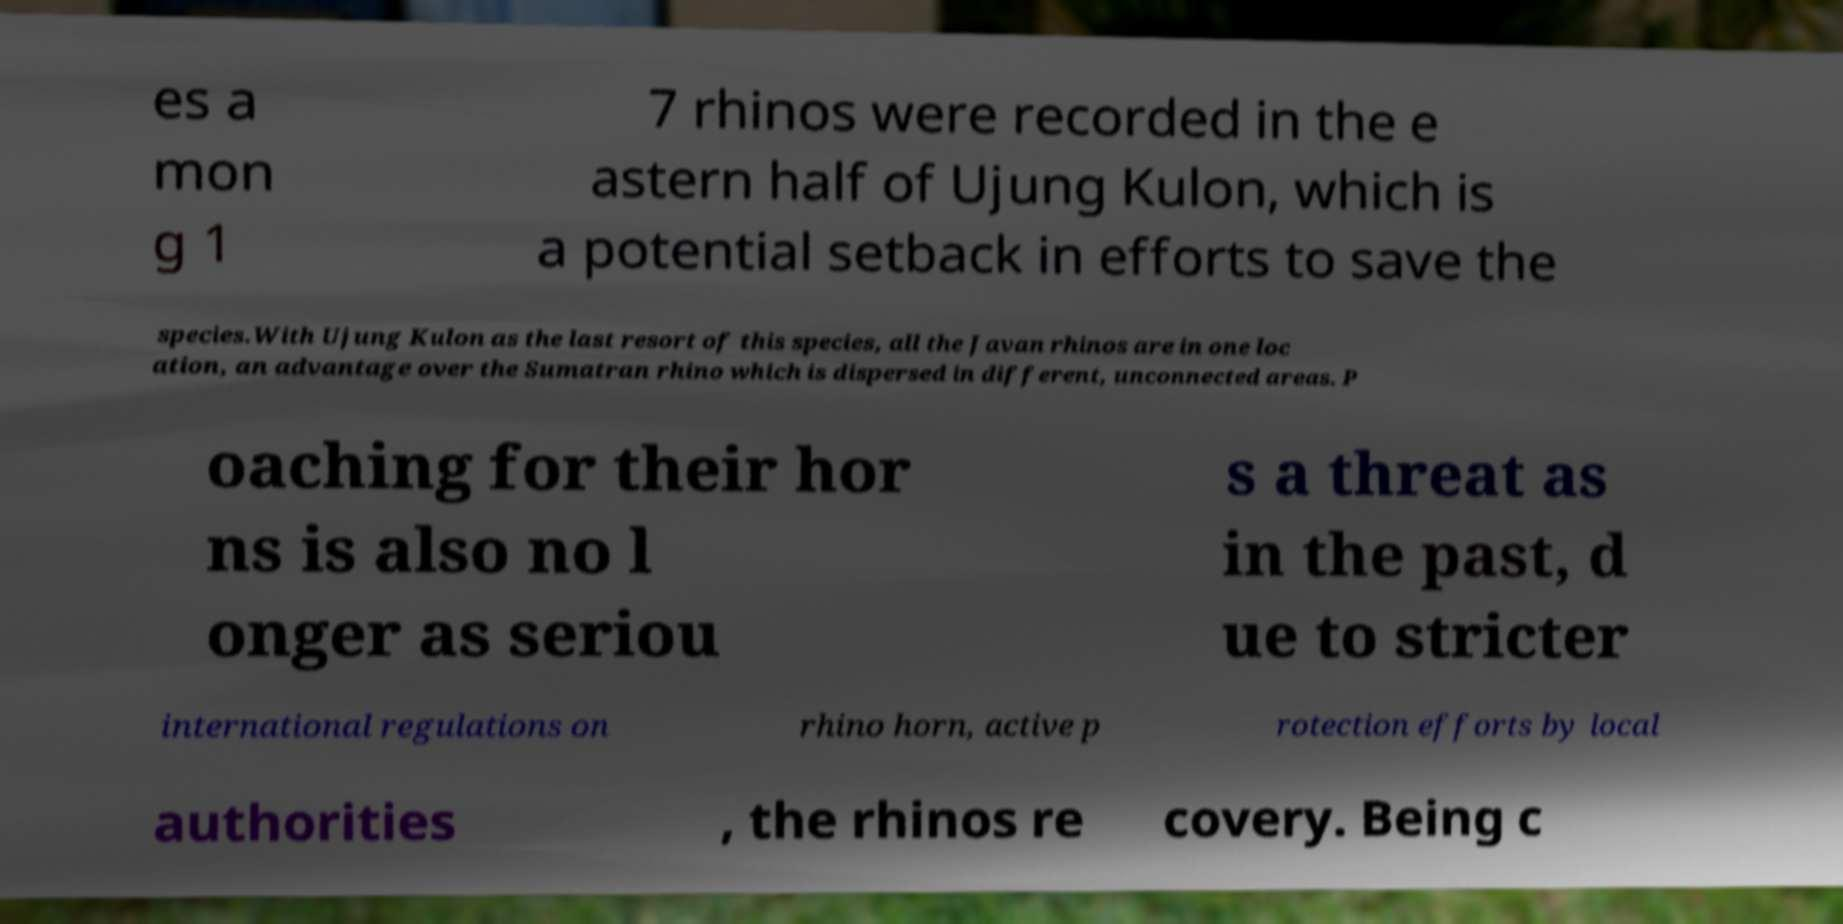Could you assist in decoding the text presented in this image and type it out clearly? es a mon g 1 7 rhinos were recorded in the e astern half of Ujung Kulon, which is a potential setback in efforts to save the species.With Ujung Kulon as the last resort of this species, all the Javan rhinos are in one loc ation, an advantage over the Sumatran rhino which is dispersed in different, unconnected areas. P oaching for their hor ns is also no l onger as seriou s a threat as in the past, d ue to stricter international regulations on rhino horn, active p rotection efforts by local authorities , the rhinos re covery. Being c 